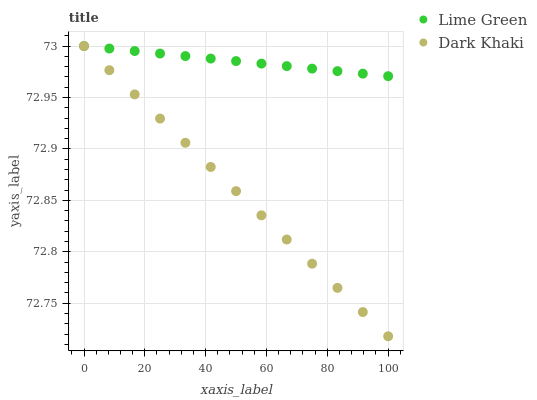Does Dark Khaki have the minimum area under the curve?
Answer yes or no. Yes. Does Lime Green have the maximum area under the curve?
Answer yes or no. Yes. Does Lime Green have the minimum area under the curve?
Answer yes or no. No. Is Dark Khaki the smoothest?
Answer yes or no. Yes. Is Lime Green the roughest?
Answer yes or no. Yes. Is Lime Green the smoothest?
Answer yes or no. No. Does Dark Khaki have the lowest value?
Answer yes or no. Yes. Does Lime Green have the lowest value?
Answer yes or no. No. Does Lime Green have the highest value?
Answer yes or no. Yes. Does Dark Khaki intersect Lime Green?
Answer yes or no. Yes. Is Dark Khaki less than Lime Green?
Answer yes or no. No. Is Dark Khaki greater than Lime Green?
Answer yes or no. No. 